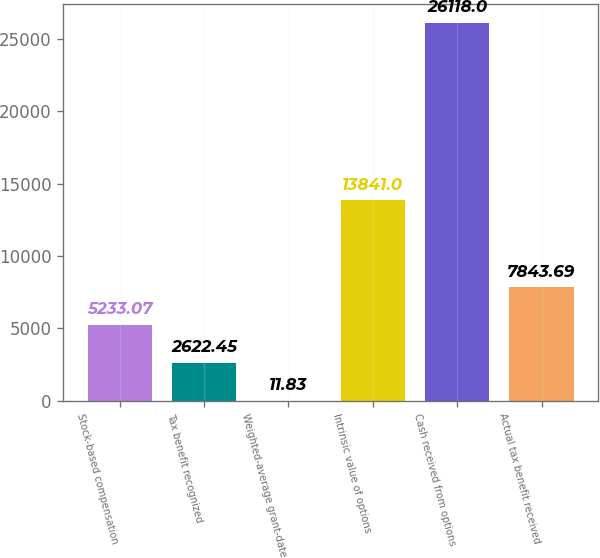Convert chart. <chart><loc_0><loc_0><loc_500><loc_500><bar_chart><fcel>Stock-based compensation<fcel>Tax benefit recognized<fcel>Weighted-average grant-date<fcel>Intrinsic value of options<fcel>Cash received from options<fcel>Actual tax benefit received<nl><fcel>5233.07<fcel>2622.45<fcel>11.83<fcel>13841<fcel>26118<fcel>7843.69<nl></chart> 